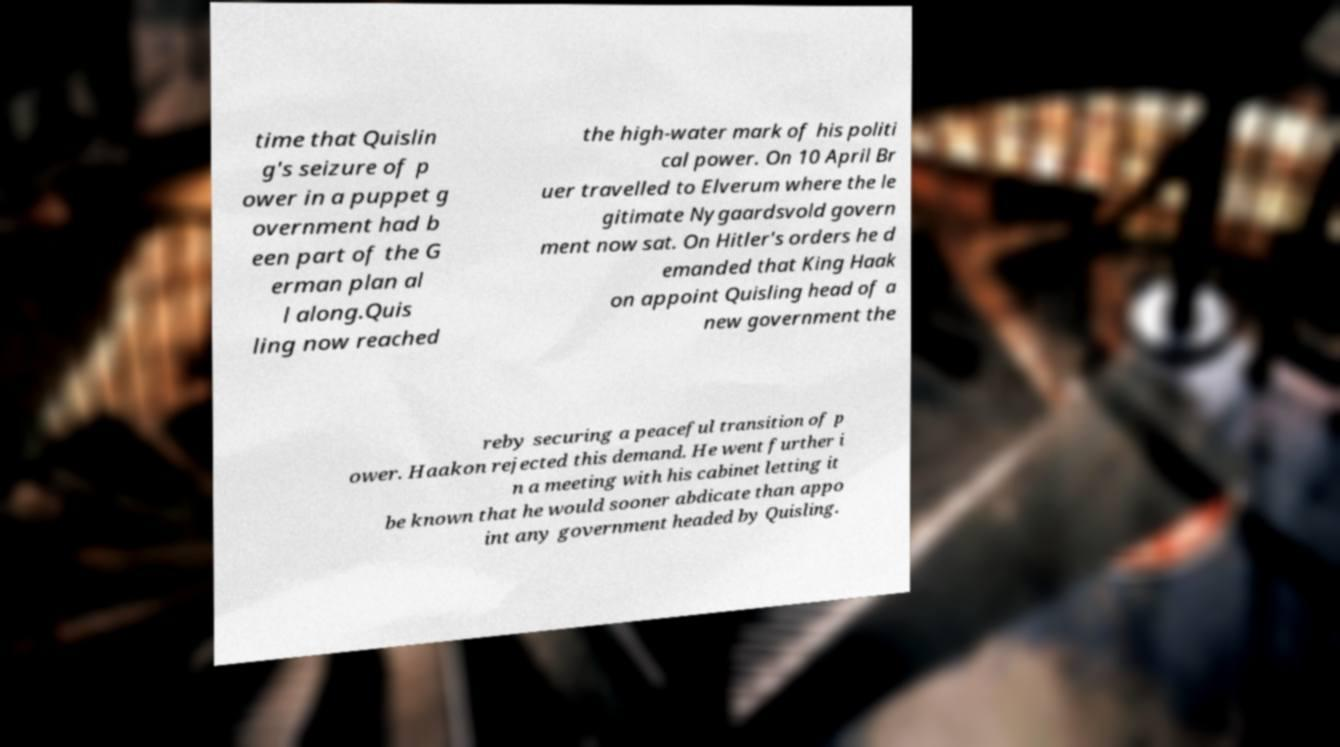Please read and relay the text visible in this image. What does it say? time that Quislin g's seizure of p ower in a puppet g overnment had b een part of the G erman plan al l along.Quis ling now reached the high-water mark of his politi cal power. On 10 April Br uer travelled to Elverum where the le gitimate Nygaardsvold govern ment now sat. On Hitler's orders he d emanded that King Haak on appoint Quisling head of a new government the reby securing a peaceful transition of p ower. Haakon rejected this demand. He went further i n a meeting with his cabinet letting it be known that he would sooner abdicate than appo int any government headed by Quisling. 